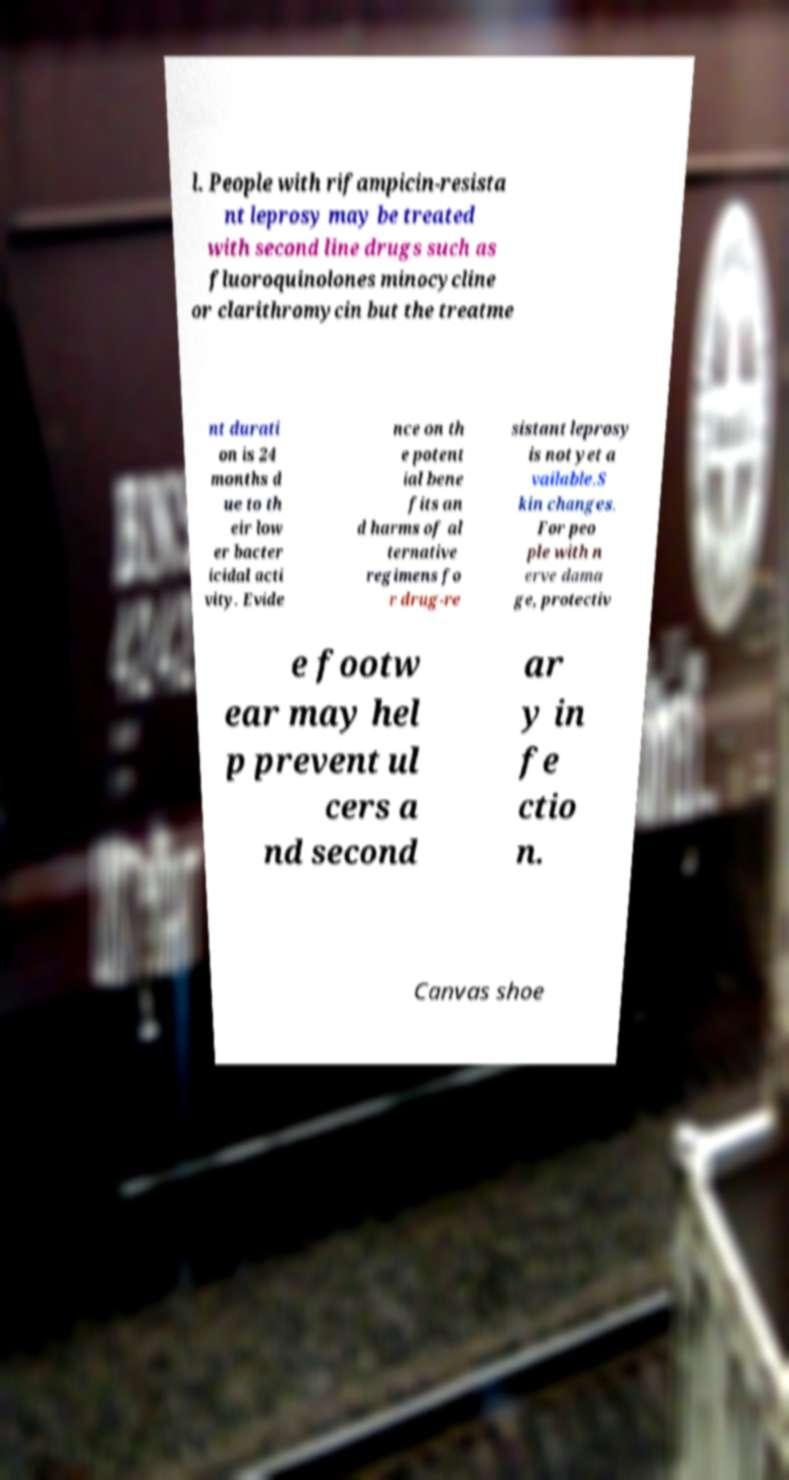Could you extract and type out the text from this image? l. People with rifampicin-resista nt leprosy may be treated with second line drugs such as fluoroquinolones minocycline or clarithromycin but the treatme nt durati on is 24 months d ue to th eir low er bacter icidal acti vity. Evide nce on th e potent ial bene fits an d harms of al ternative regimens fo r drug-re sistant leprosy is not yet a vailable.S kin changes. For peo ple with n erve dama ge, protectiv e footw ear may hel p prevent ul cers a nd second ar y in fe ctio n. Canvas shoe 